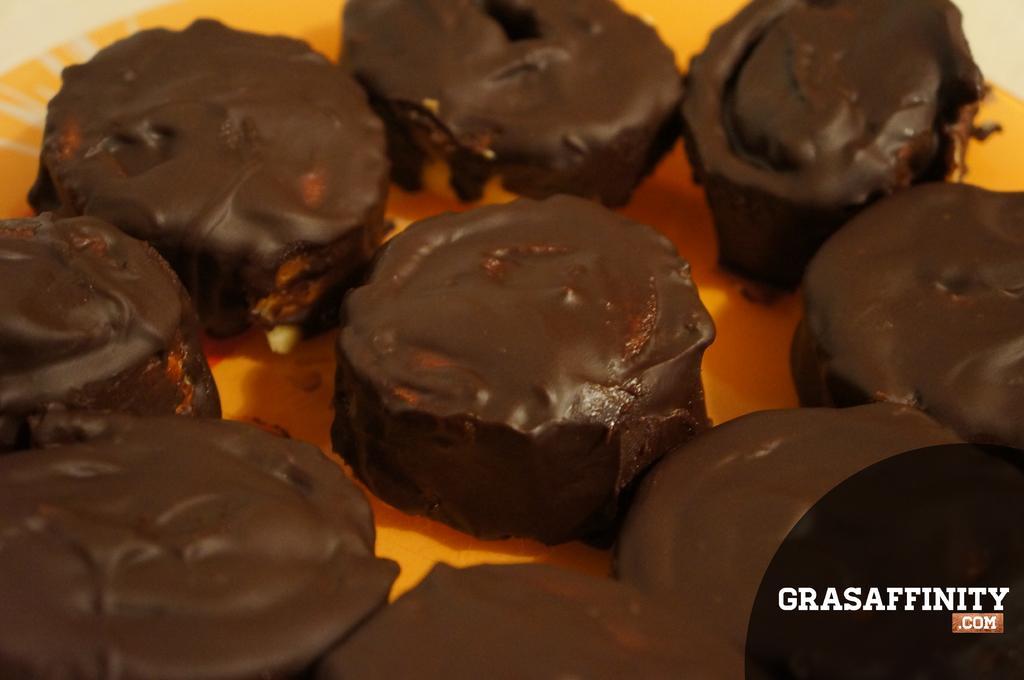Describe this image in one or two sentences. In this picture we can see a plate which contain desserts. In the bottom right corner we can see the text. 